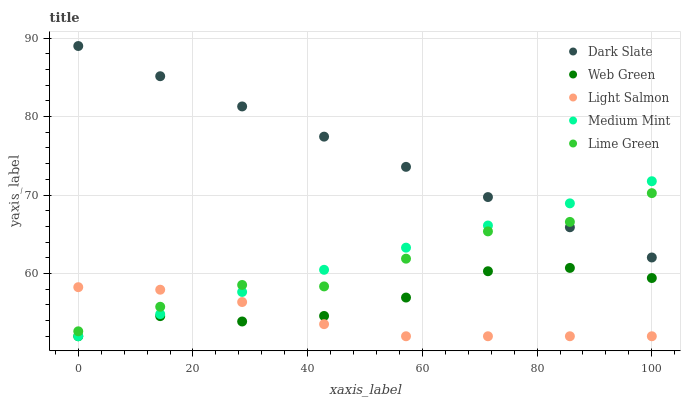Does Light Salmon have the minimum area under the curve?
Answer yes or no. Yes. Does Dark Slate have the maximum area under the curve?
Answer yes or no. Yes. Does Dark Slate have the minimum area under the curve?
Answer yes or no. No. Does Light Salmon have the maximum area under the curve?
Answer yes or no. No. Is Medium Mint the smoothest?
Answer yes or no. Yes. Is Web Green the roughest?
Answer yes or no. Yes. Is Dark Slate the smoothest?
Answer yes or no. No. Is Dark Slate the roughest?
Answer yes or no. No. Does Medium Mint have the lowest value?
Answer yes or no. Yes. Does Dark Slate have the lowest value?
Answer yes or no. No. Does Dark Slate have the highest value?
Answer yes or no. Yes. Does Light Salmon have the highest value?
Answer yes or no. No. Is Web Green less than Lime Green?
Answer yes or no. Yes. Is Lime Green greater than Web Green?
Answer yes or no. Yes. Does Lime Green intersect Light Salmon?
Answer yes or no. Yes. Is Lime Green less than Light Salmon?
Answer yes or no. No. Is Lime Green greater than Light Salmon?
Answer yes or no. No. Does Web Green intersect Lime Green?
Answer yes or no. No. 